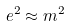Convert formula to latex. <formula><loc_0><loc_0><loc_500><loc_500>e ^ { 2 } \approx m ^ { 2 }</formula> 